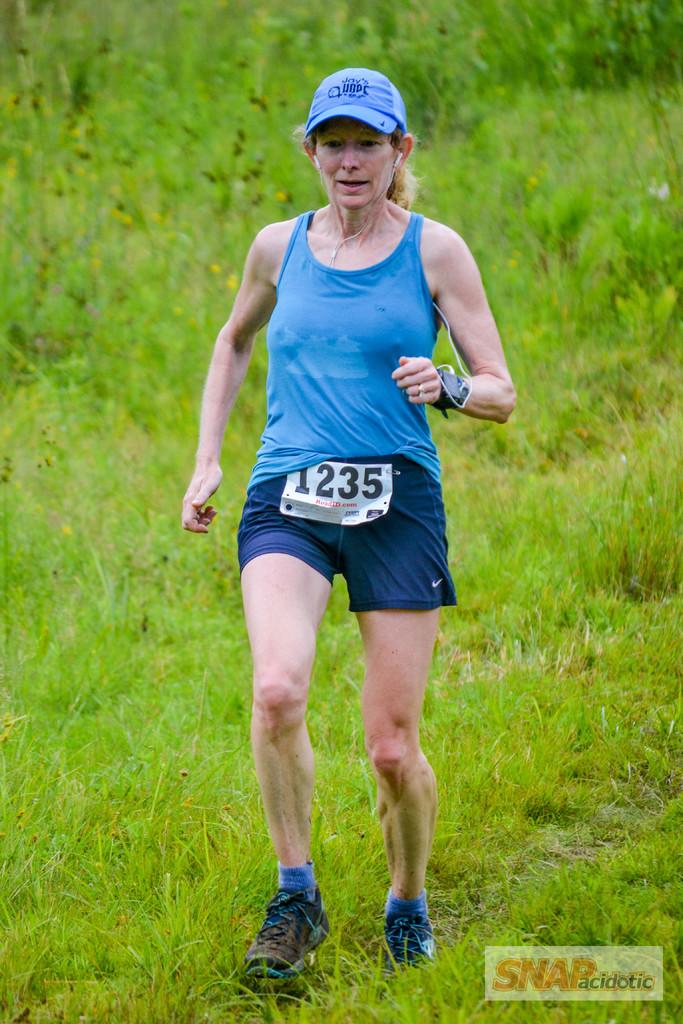Does her hat say joy hope?
Offer a very short reply. Yes. What number is printed on the woman's tag?
Ensure brevity in your answer.  1235. 